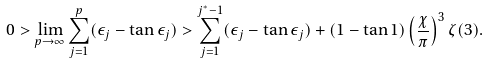<formula> <loc_0><loc_0><loc_500><loc_500>0 > \lim _ { p \rightarrow \infty } \sum _ { j = 1 } ^ { p } ( \epsilon _ { j } - \tan \epsilon _ { j } ) > \sum _ { j = 1 } ^ { j ^ { * } - 1 } ( \epsilon _ { j } - \tan \epsilon _ { j } ) + ( 1 - \tan 1 ) \left ( \frac { \chi } { \pi } \right ) ^ { 3 } \zeta ( 3 ) .</formula> 